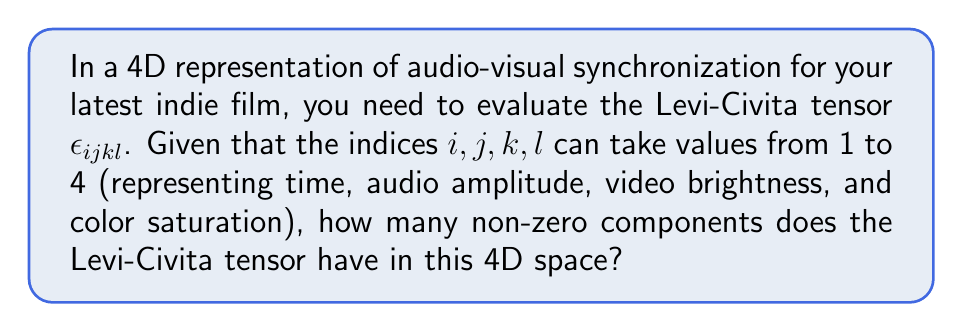Can you solve this math problem? To evaluate the Levi-Civita tensor in 4D, let's follow these steps:

1) The Levi-Civita tensor $\epsilon_{ijkl}$ in 4D has the following properties:
   - It is completely antisymmetric in all indices.
   - Its value is +1 for even permutations of (1,2,3,4).
   - Its value is -1 for odd permutations of (1,2,3,4).
   - Its value is 0 if any two indices are the same.

2) To count the non-zero components, we need to count the number of permutations of (1,2,3,4).

3) The total number of permutations of 4 distinct elements is 4! = 24.

4) Half of these permutations will be even (yielding +1), and half will be odd (yielding -1).

5) Therefore, there are 12 even permutations and 12 odd permutations.

6) Each permutation corresponds to a non-zero component of the Levi-Civita tensor.

7) Thus, the total number of non-zero components is 12 + 12 = 24.

This means that in your 4D audio-visual synchronization space, there are 24 ways to arrange the indices of the Levi-Civita tensor that result in non-zero values, representing various relationships between time, audio amplitude, video brightness, and color saturation in your indie film.
Answer: 24 